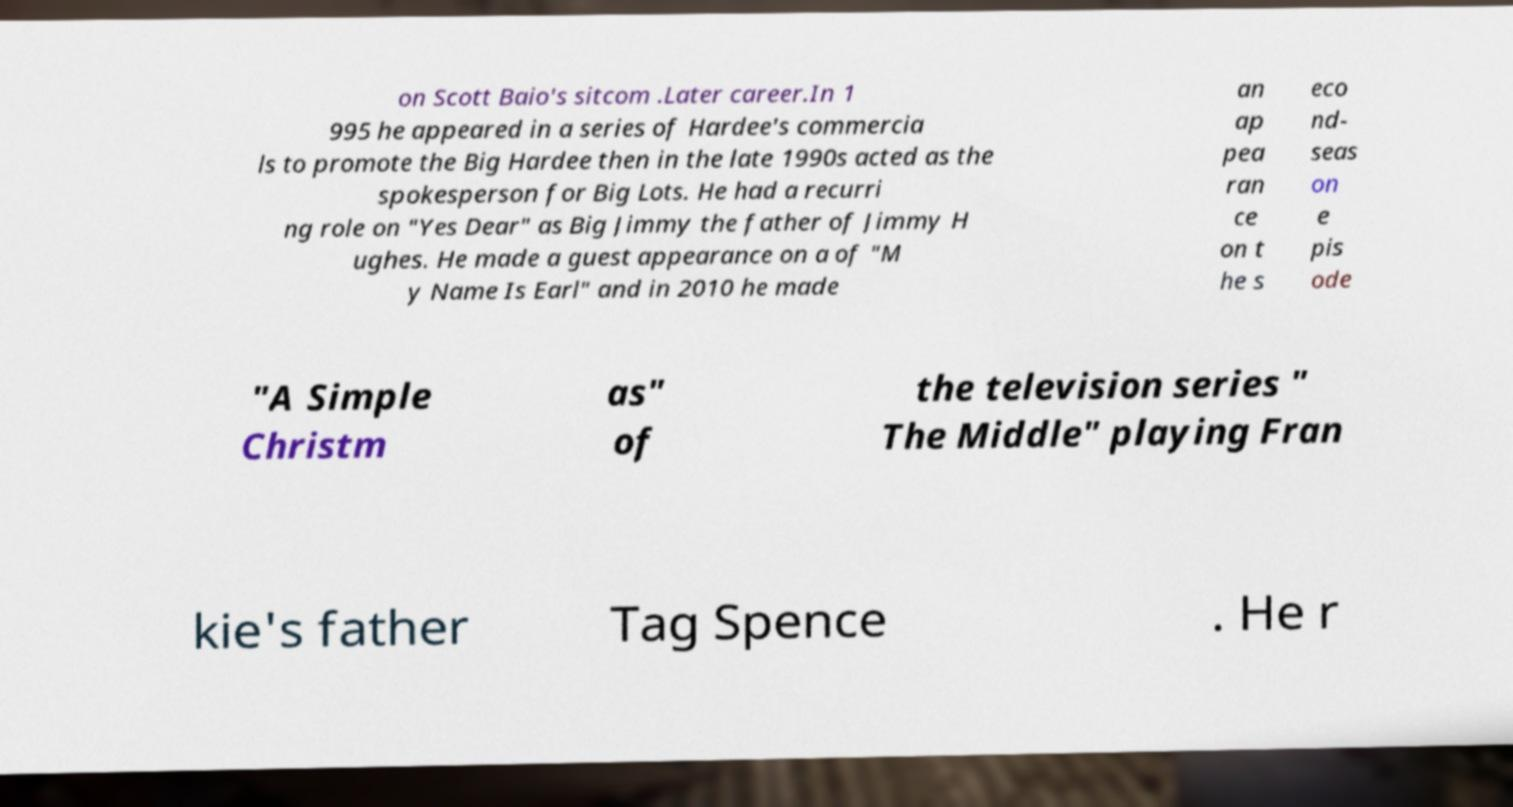There's text embedded in this image that I need extracted. Can you transcribe it verbatim? on Scott Baio's sitcom .Later career.In 1 995 he appeared in a series of Hardee's commercia ls to promote the Big Hardee then in the late 1990s acted as the spokesperson for Big Lots. He had a recurri ng role on "Yes Dear" as Big Jimmy the father of Jimmy H ughes. He made a guest appearance on a of "M y Name Is Earl" and in 2010 he made an ap pea ran ce on t he s eco nd- seas on e pis ode "A Simple Christm as" of the television series " The Middle" playing Fran kie's father Tag Spence . He r 